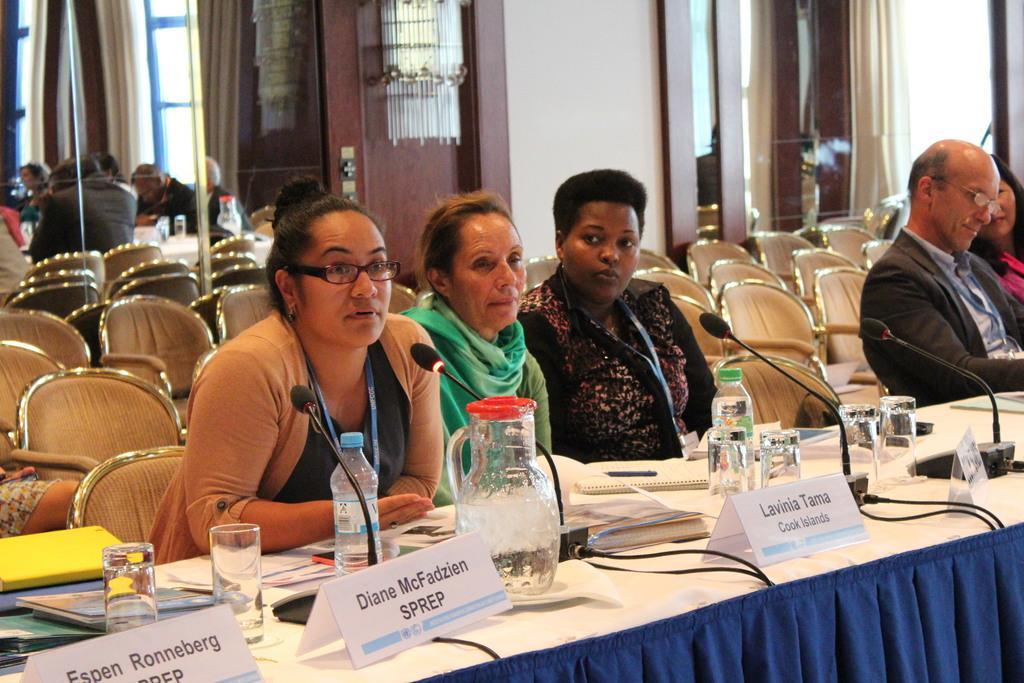In one or two sentences, can you explain what this image depicts? In this picture we can see few persons sitting on the chairs in front of a table and on the table we can see nameboards, jar, glasses , water bottles and mikes. These are empty chairs. Here we can see few persons sitting on the chairs. 